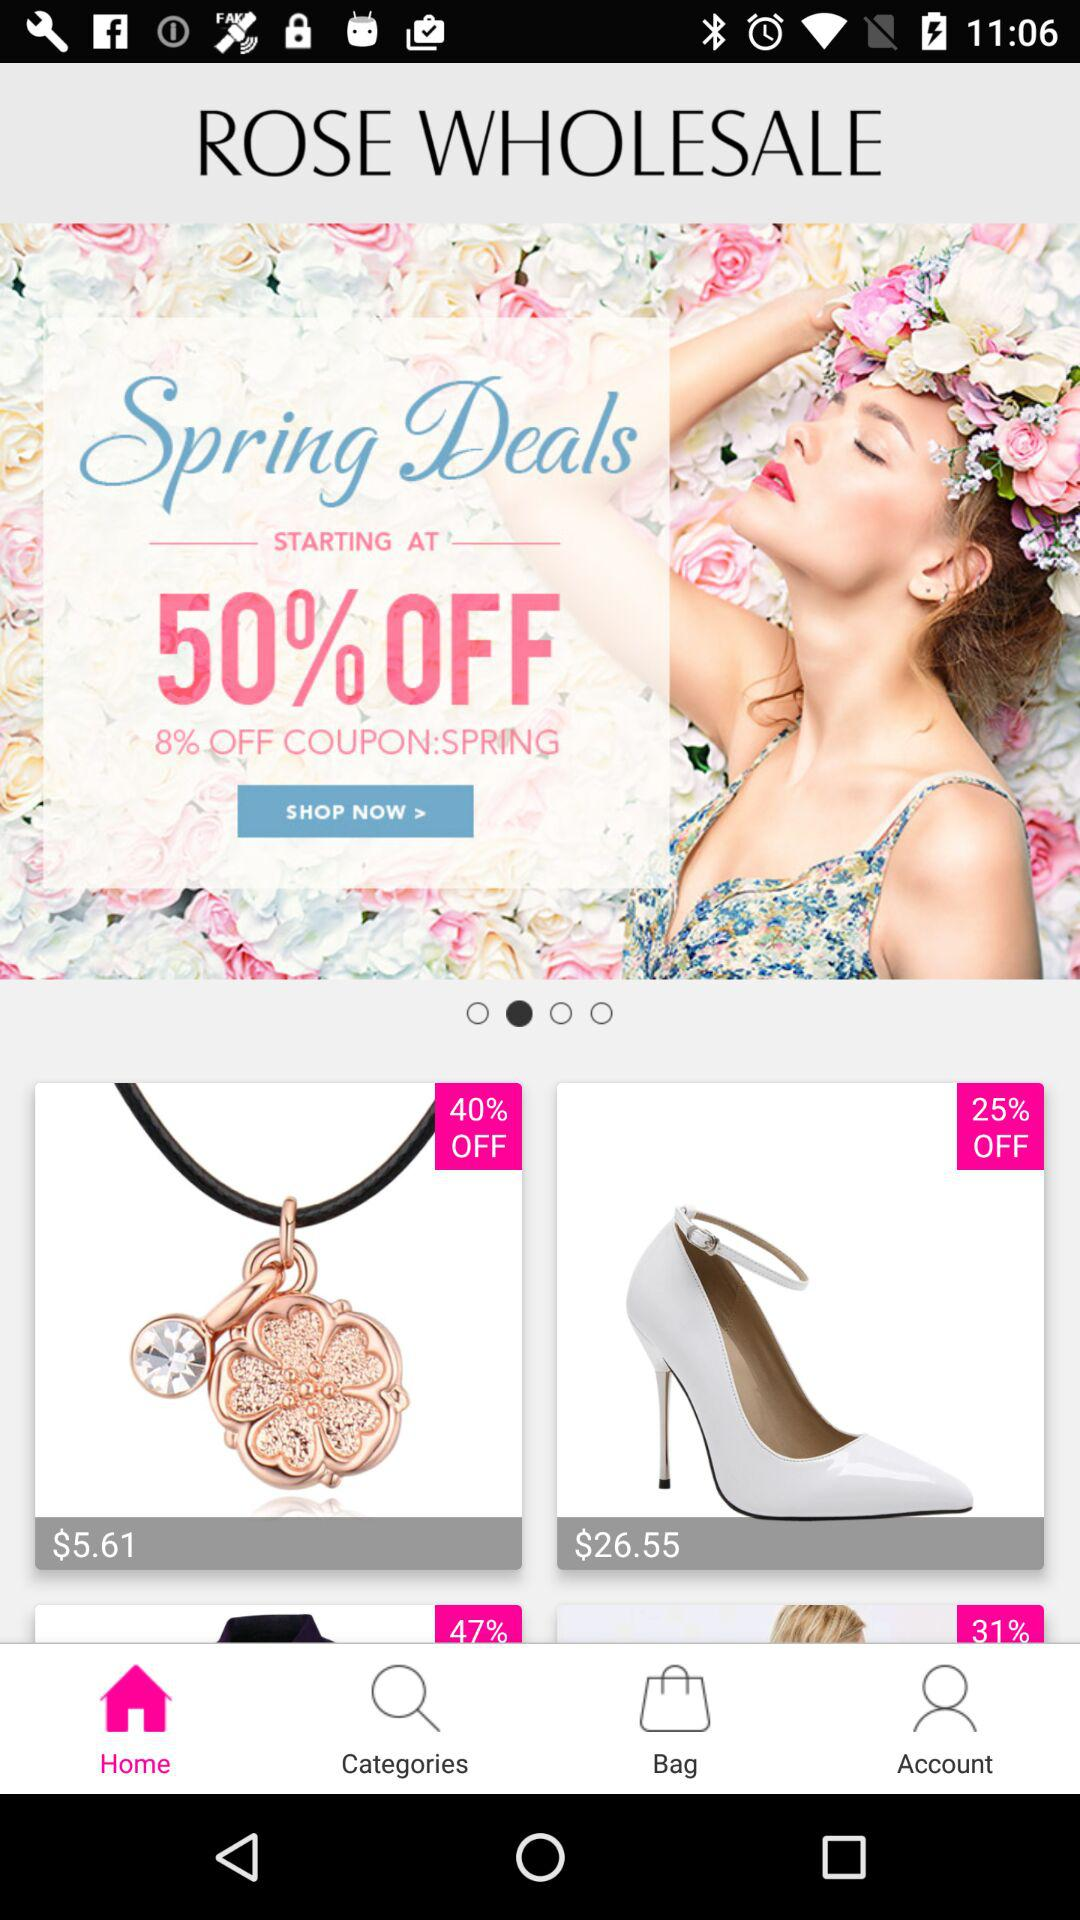Which tab is selected? The selected tab is "Home". 